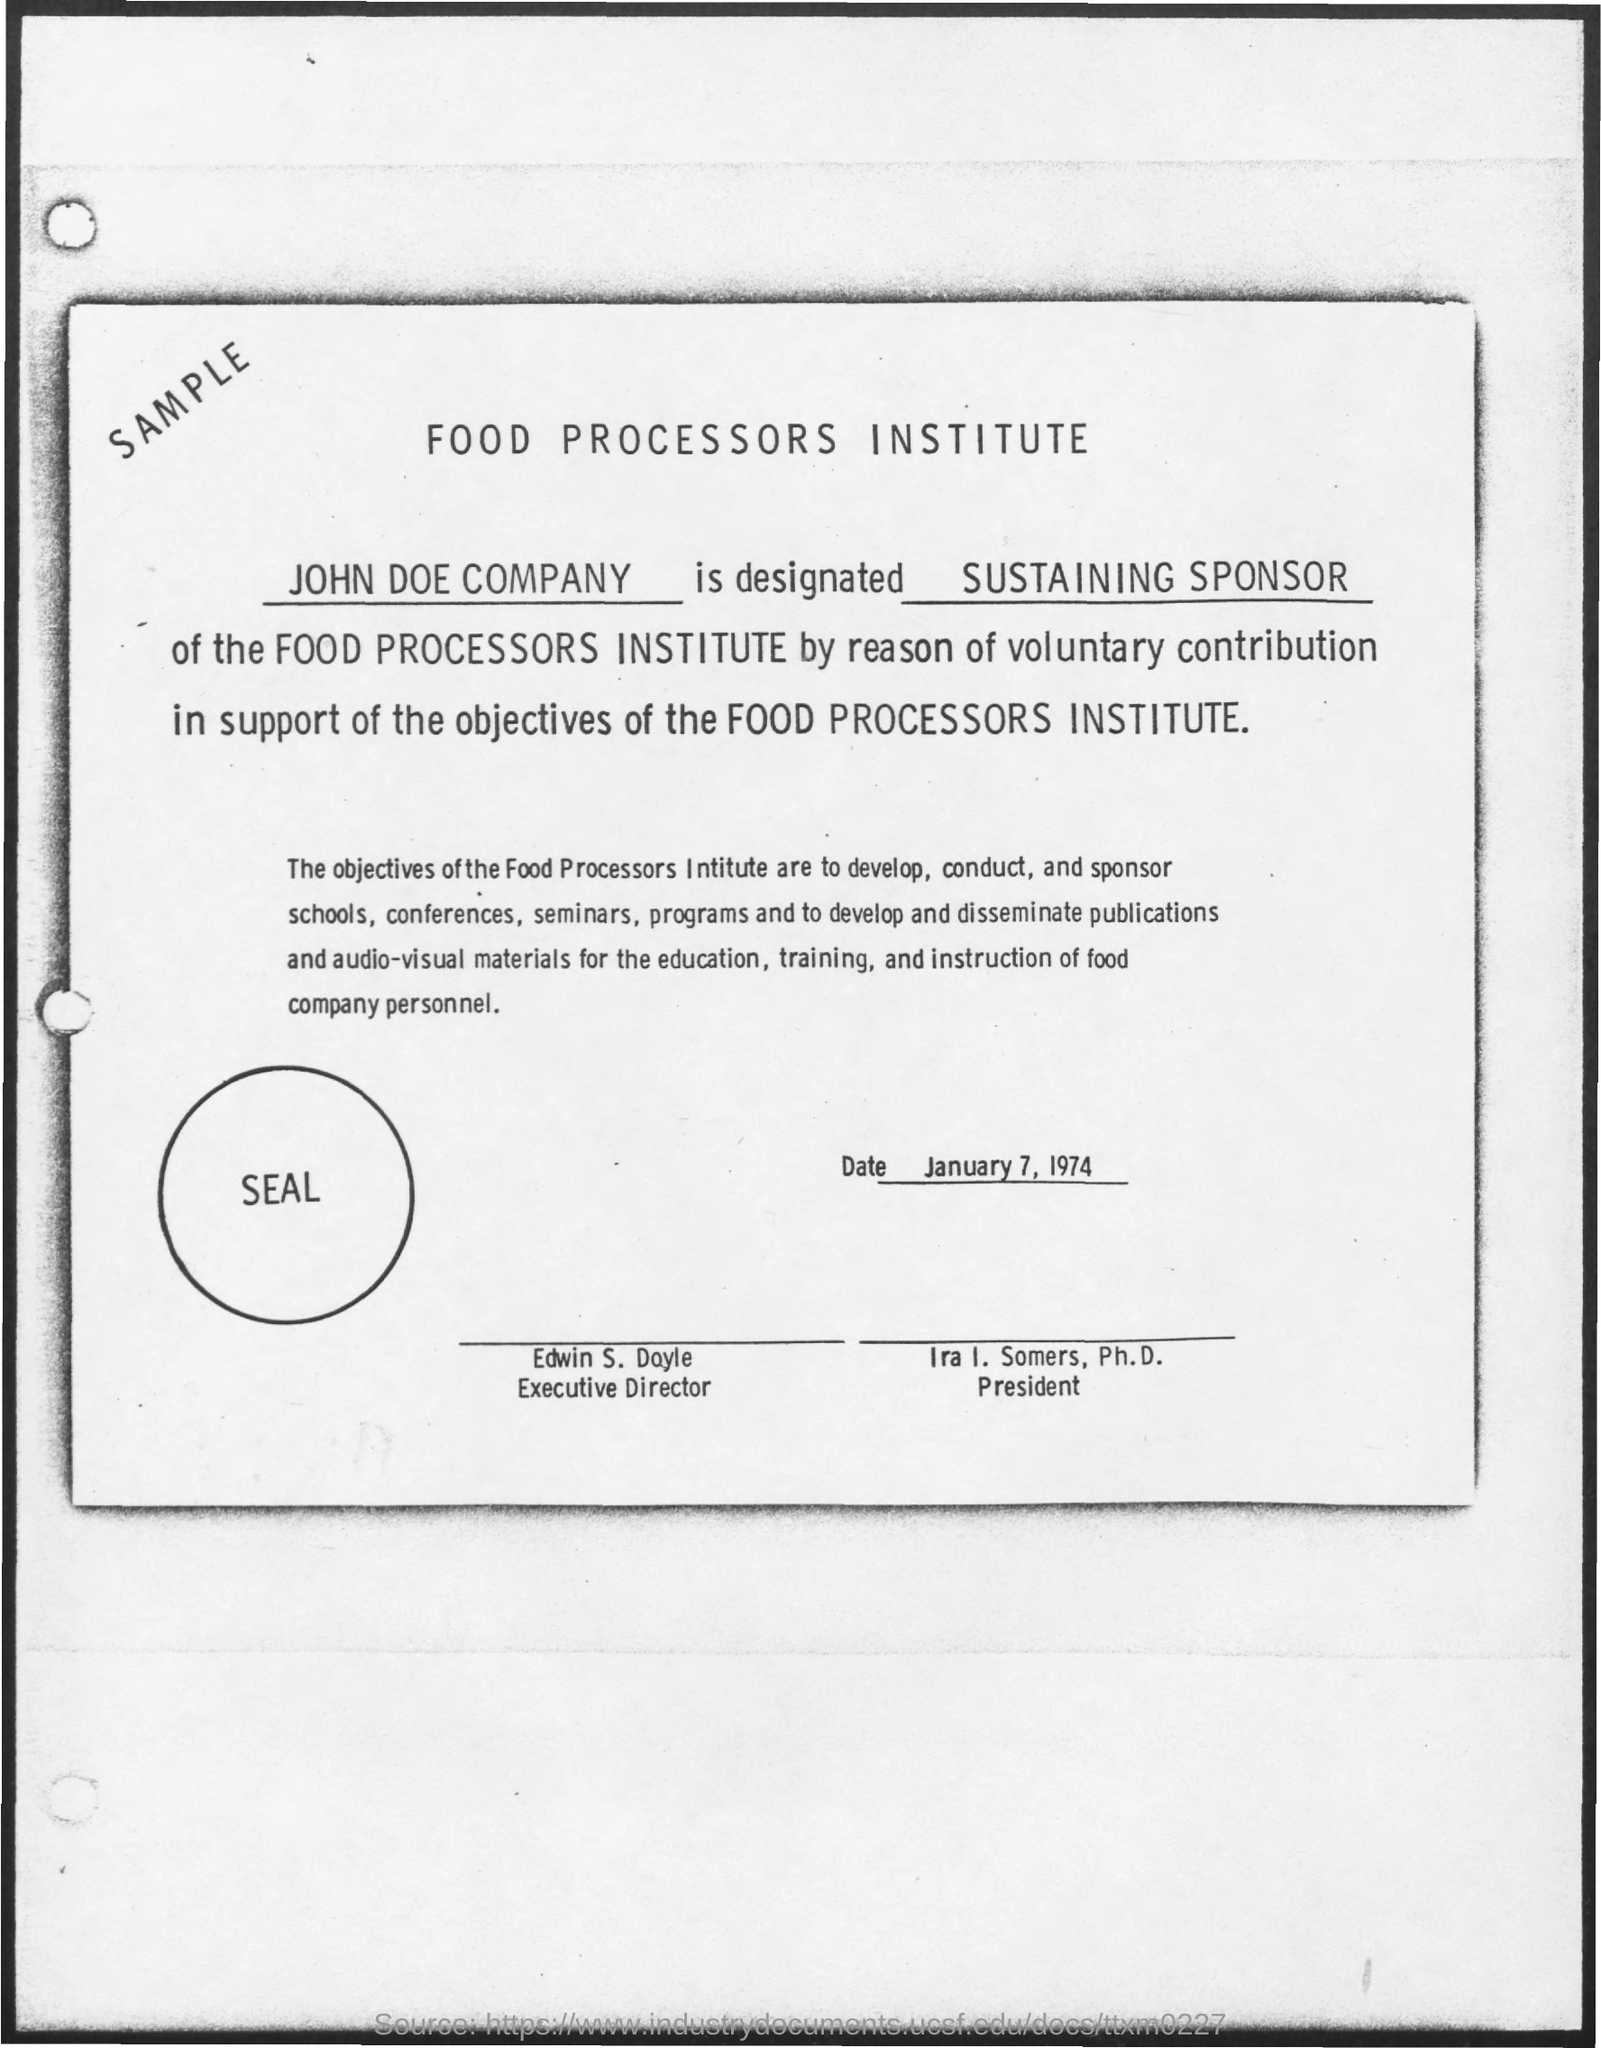Draw attention to some important aspects in this diagram. The executive director is Edwin S. Doyle. The document states that the date mentioned is January 7, 1974. The title of the document is the Food Processors Institute. The text that is enclosed within a circle is 'seal'. The text located at the top-left corner is "Sample...". 